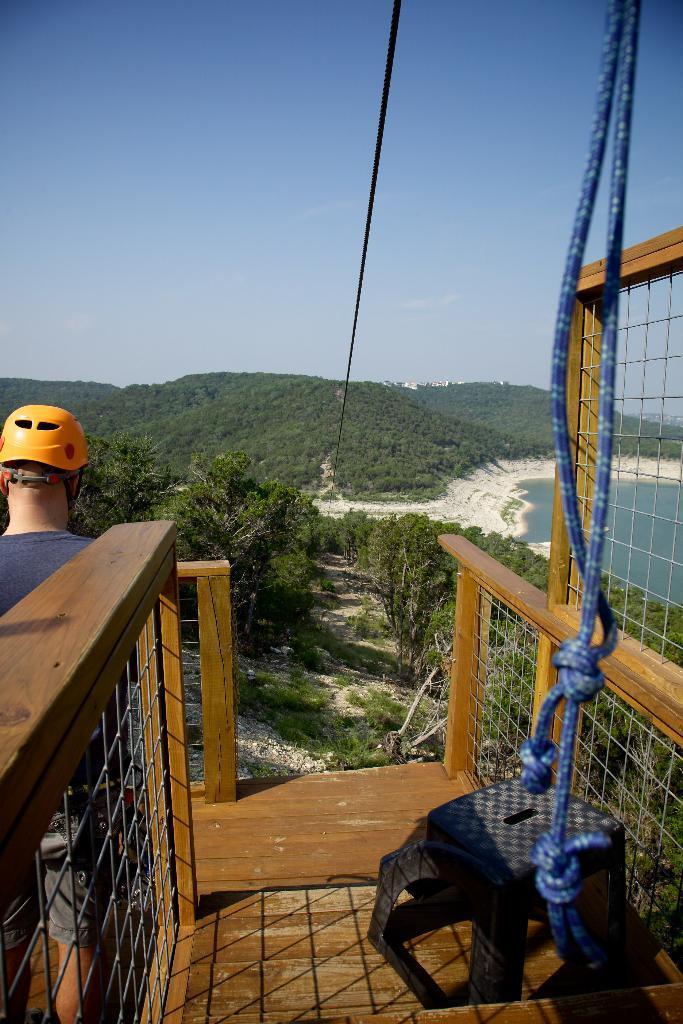Please provide a concise description of this image. In this picture we can see a man is standing on the wooden floor and on the right side of the man there is a rope and a fence. In front of the man there is a cable, trees, hills, water and a sky. 